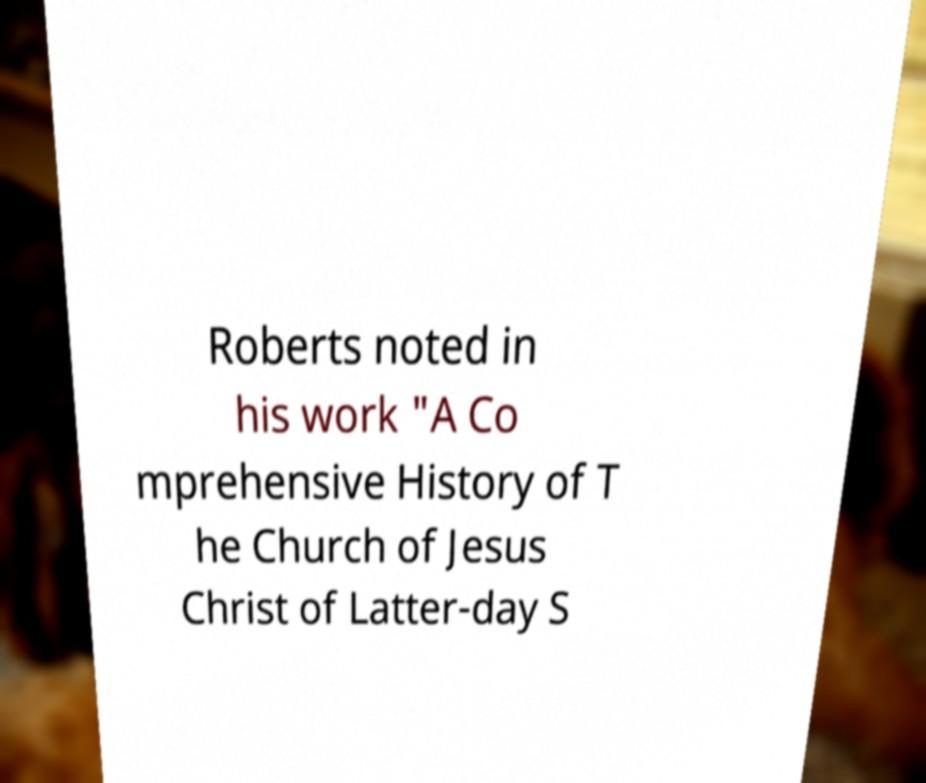Can you read and provide the text displayed in the image?This photo seems to have some interesting text. Can you extract and type it out for me? Roberts noted in his work "A Co mprehensive History of T he Church of Jesus Christ of Latter-day S 